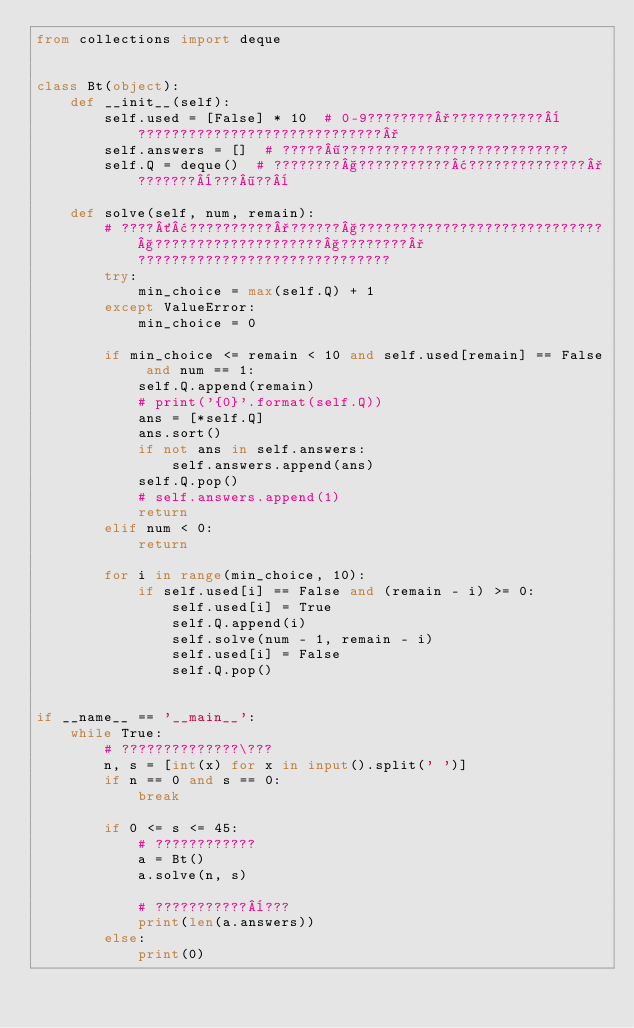<code> <loc_0><loc_0><loc_500><loc_500><_Python_>from collections import deque


class Bt(object):
    def __init__(self):
        self.used = [False] * 10  # 0-9????????°???????????¨?????????????????????????????°
        self.answers = []  # ?????¶???????????????????????????
        self.Q = deque()  # ????????§???????????¢??????????????°???????¨???¶??¨

    def solve(self, num, remain):
        # ????´¢??????????°??????§?????????????????????????????§????????????????????§????????°??????????????????????????????
        try:
            min_choice = max(self.Q) + 1
        except ValueError:
            min_choice = 0

        if min_choice <= remain < 10 and self.used[remain] == False and num == 1:
            self.Q.append(remain)
            # print('{0}'.format(self.Q))
            ans = [*self.Q]
            ans.sort()
            if not ans in self.answers:
                self.answers.append(ans)
            self.Q.pop()
            # self.answers.append(1)
            return
        elif num < 0:
            return

        for i in range(min_choice, 10):
            if self.used[i] == False and (remain - i) >= 0:
                self.used[i] = True
                self.Q.append(i)
                self.solve(num - 1, remain - i)
                self.used[i] = False
                self.Q.pop()


if __name__ == '__main__':
    while True:
        # ??????????????\???
        n, s = [int(x) for x in input().split(' ')]
        if n == 0 and s == 0:
            break

        if 0 <= s <= 45:
            # ????????????
            a = Bt()
            a.solve(n, s)

            # ???????????¨???
            print(len(a.answers))
        else:
            print(0)</code> 